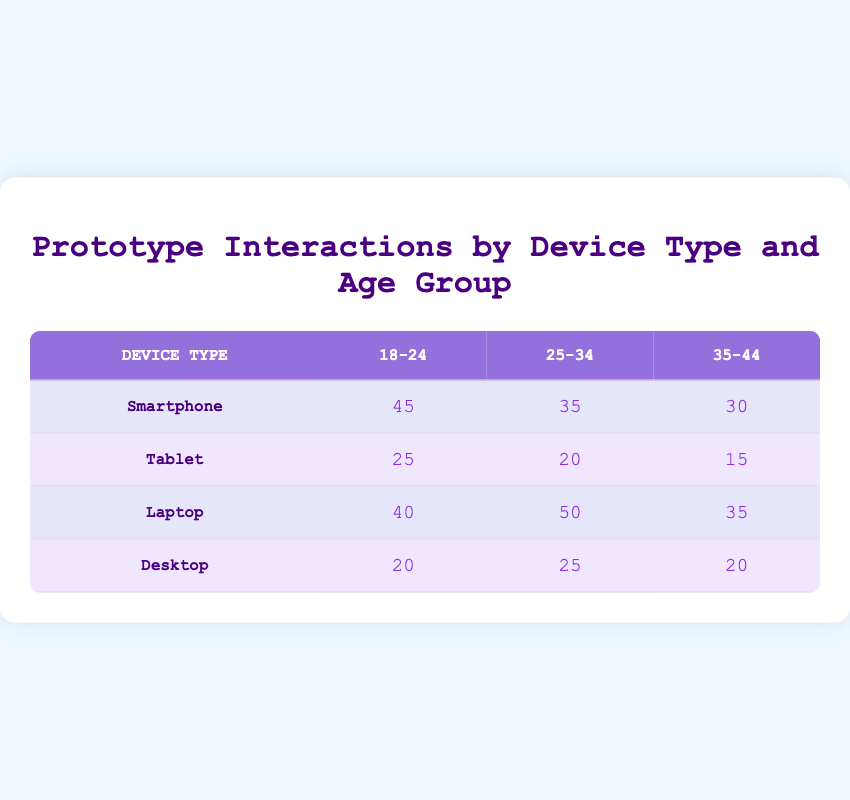What is the interaction frequency for smartphones in the 18-24 age group? Referring to the table, the interaction frequency for smartphones in the 18-24 age group is clearly stated as 45.
Answer: 45 Which device type has the highest interaction frequency in the 25-34 age group? By comparing the values for the 25-34 age group across all device types, the highest frequency is 50 for laptops.
Answer: Laptop What is the total interaction frequency for tablets? The interaction frequencies for tablets are 25, 20, and 15 for the 18-24, 25-34, and 35-44 age groups respectively. Summing these gives: 25 + 20 + 15 = 60.
Answer: 60 Is the interaction frequency for desktops in the 35-44 age group greater than that for tablets in the same age group? The frequency for desktops in the 35-44 age group is 20, while for tablets it is 15. Since 20 is greater than 15, the statement is true.
Answer: Yes What is the average interaction frequency for smartphones across all age groups? The interaction frequencies for smartphones are 45, 35, and 30 for the respective age groups. The sum is 45 + 35 + 30 = 110. Since there are 3 age groups, the average is 110 / 3 = approximately 36.67.
Answer: Approximately 36.67 Which age group has the lowest interaction frequency for laptops? Looking at the values for laptops, the frequencies are 40, 50, and 35 for the respective age groups. The lowest value is 35 for the 35-44 age group.
Answer: 35-44 How does the total interaction frequency for the 18-24 age group compare among all devices? The interaction frequencies for the 18-24 age group are 45 (smartphone), 25 (tablet), 40 (laptop), and 20 (desktop). Summing these gives: 45 + 25 + 40 + 20 = 130. The smartphone has the highest individual frequency.
Answer: 130 Are there more interactions for smartphones in the 25-34 age group than for tablets in the same group? The smartphone frequency for the 25-34 age group is 35, while the tablet frequency is 20. Because 35 is greater than 20, the statement is true.
Answer: Yes What is the difference in interaction frequency between the highest and lowest device type in the 35-44 age group? The highest frequency is 35 (laptop) and the lowest is 15 (tablet) for the 35-44 age group. The difference is calculated as 35 - 15 = 20.
Answer: 20 